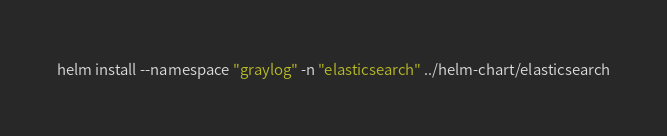Convert code to text. <code><loc_0><loc_0><loc_500><loc_500><_Bash_>helm install --namespace "graylog" -n "elasticsearch" ../helm-chart/elasticsearch
</code> 